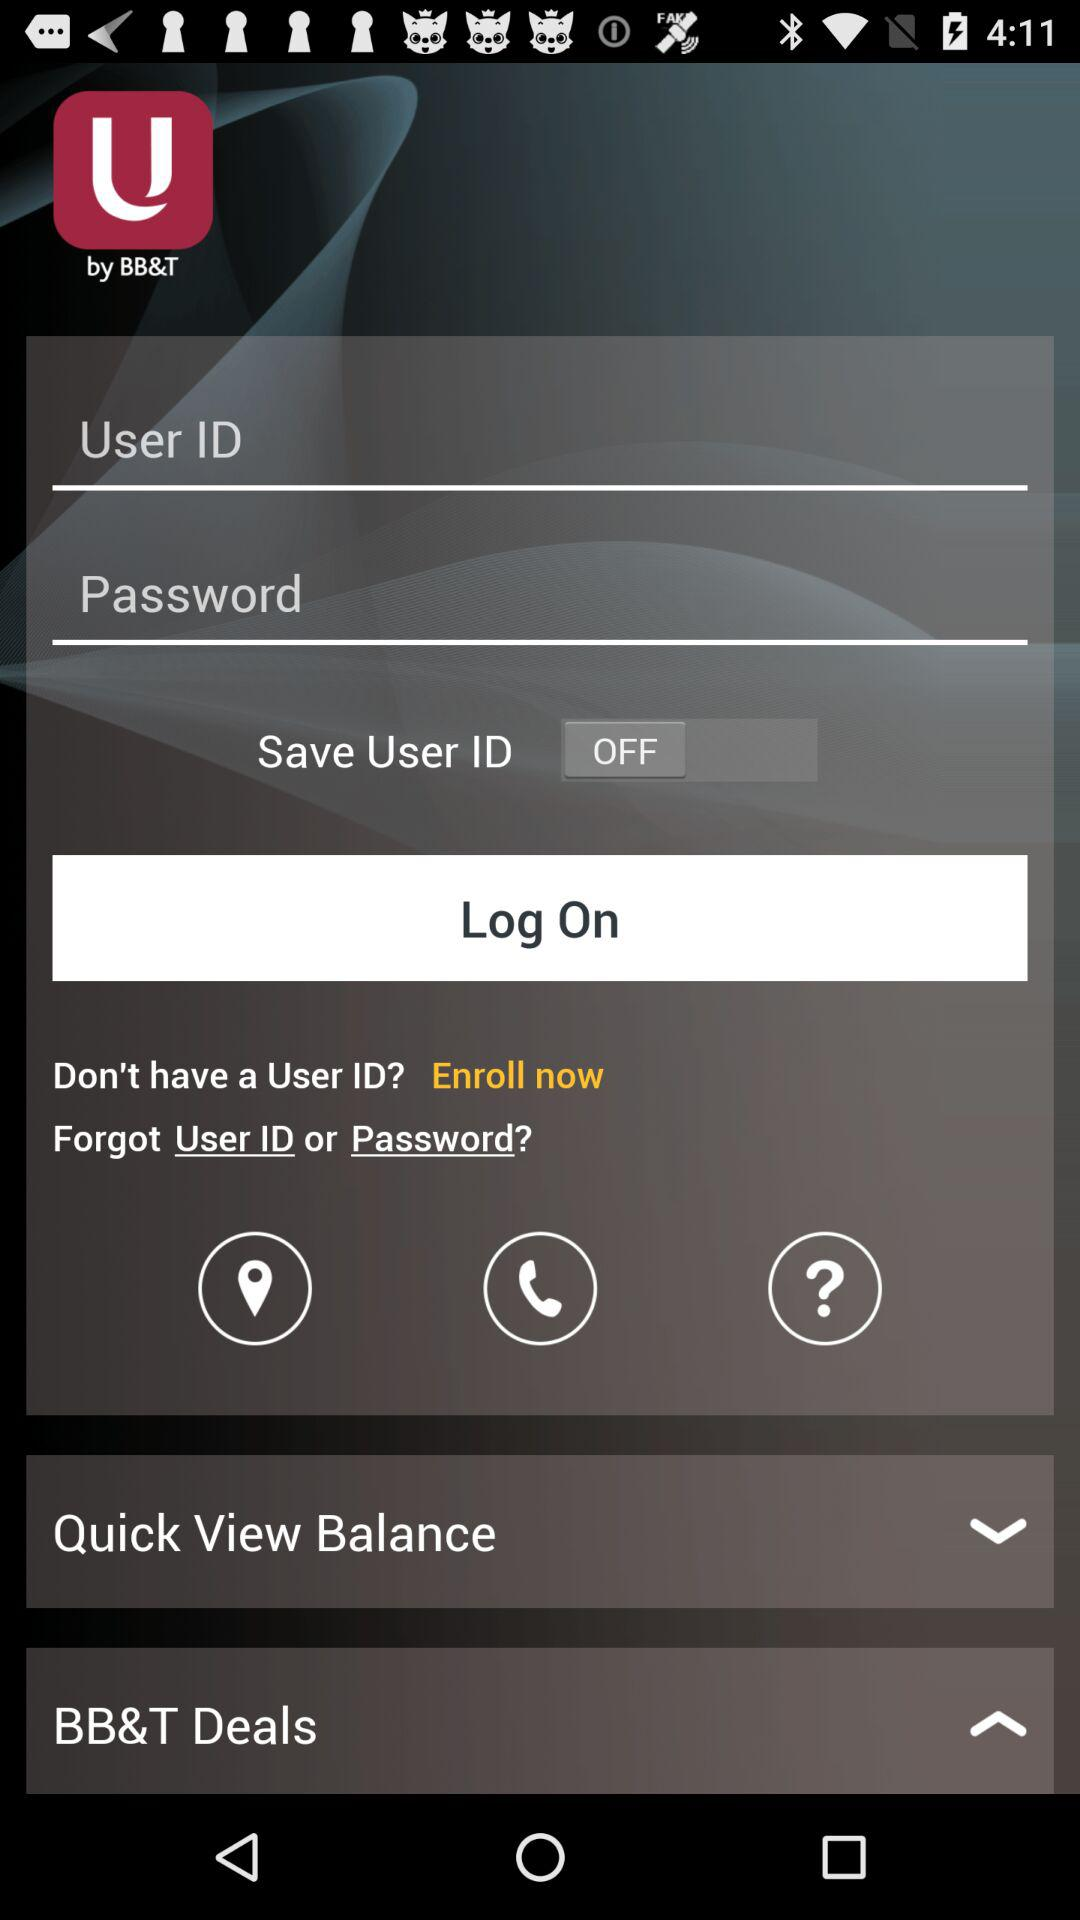What is the status of "Save User ID"? The status is "off". 